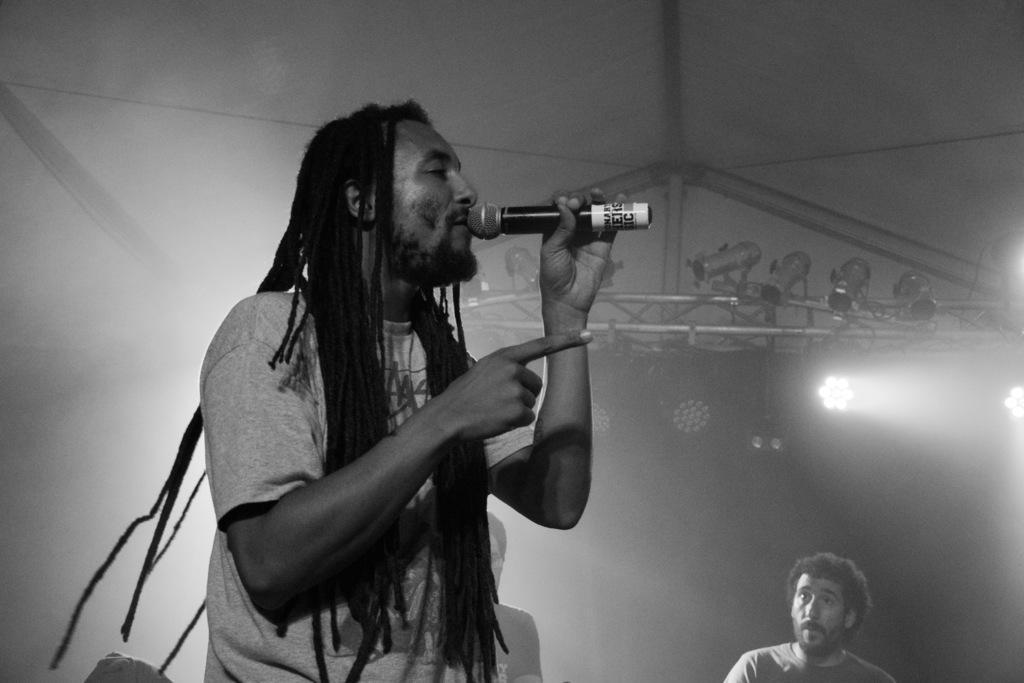Could you give a brief overview of what you see in this image? In the middle of the picture, man in grey t-shirt is holding microphone in his hand and singing on it. Beside him, we see two men sitting and this picture is taken in a musical concert and this is a black and white picture. 